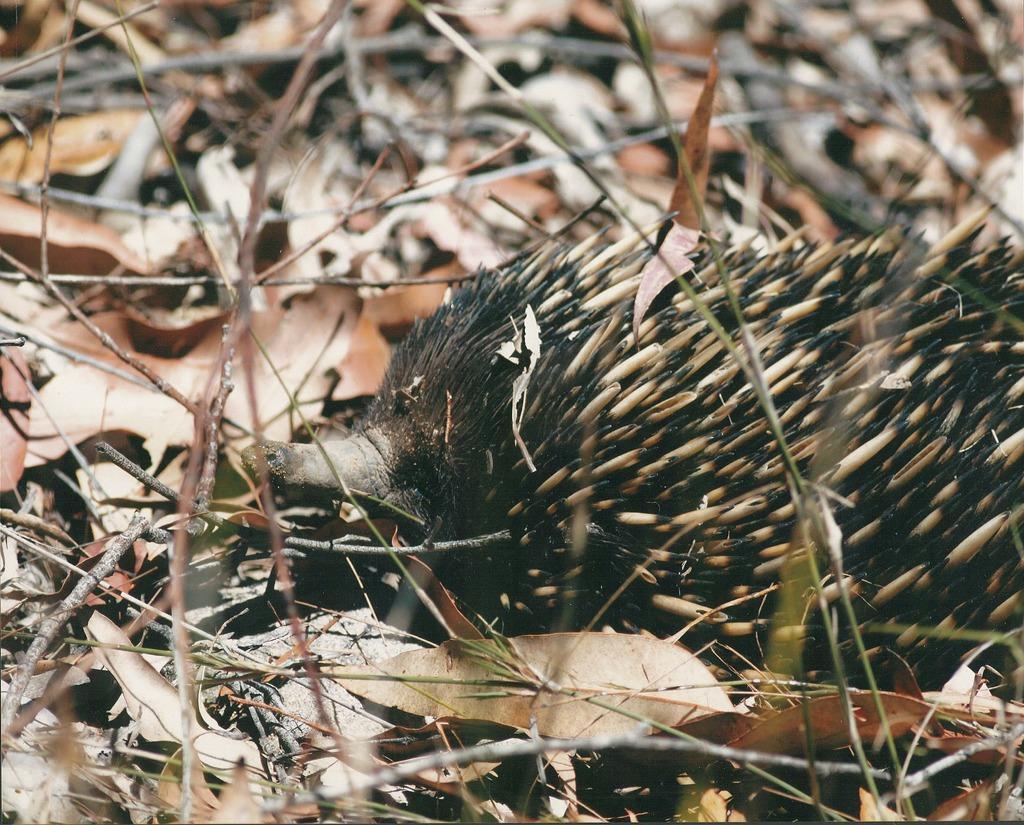Could you give a brief overview of what you see in this image? In this image we can see dry leaves, twigs and other objects. 